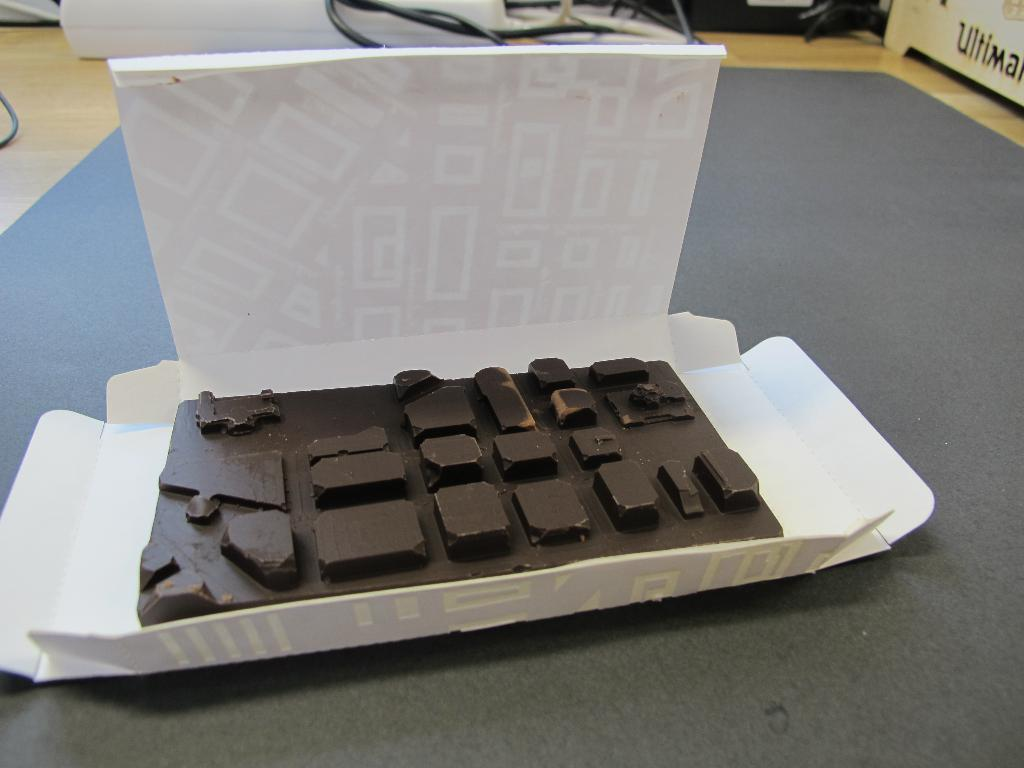What is the main subject of the image? The main subject of the image is a chocolate. What can be observed on the surface of the chocolate? The chocolate has shapes on it. On what is the chocolate placed? The chocolate is placed on a sheet. What can be seen in the background of the image? There are cables and other objects in the background of the image. What type of horn can be heard in the image? There is no horn present in the image, and therefore no sound can be heard. Can you tell me how many volleyballs are visible in the image? There are no volleyballs present in the image. 